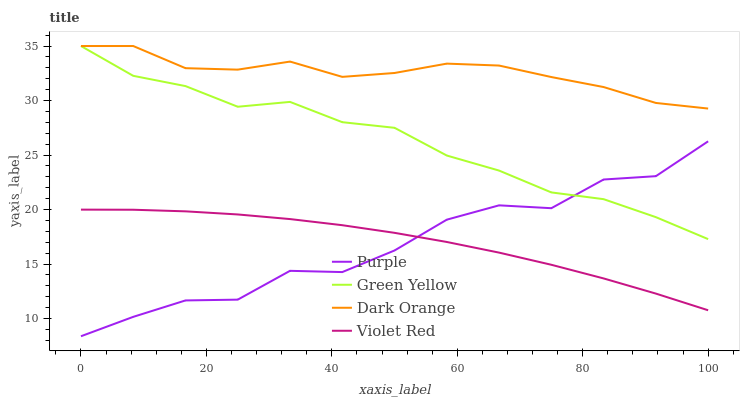Does Purple have the minimum area under the curve?
Answer yes or no. Yes. Does Dark Orange have the maximum area under the curve?
Answer yes or no. Yes. Does Violet Red have the minimum area under the curve?
Answer yes or no. No. Does Violet Red have the maximum area under the curve?
Answer yes or no. No. Is Violet Red the smoothest?
Answer yes or no. Yes. Is Purple the roughest?
Answer yes or no. Yes. Is Dark Orange the smoothest?
Answer yes or no. No. Is Dark Orange the roughest?
Answer yes or no. No. Does Purple have the lowest value?
Answer yes or no. Yes. Does Violet Red have the lowest value?
Answer yes or no. No. Does Green Yellow have the highest value?
Answer yes or no. Yes. Does Violet Red have the highest value?
Answer yes or no. No. Is Violet Red less than Green Yellow?
Answer yes or no. Yes. Is Green Yellow greater than Violet Red?
Answer yes or no. Yes. Does Purple intersect Violet Red?
Answer yes or no. Yes. Is Purple less than Violet Red?
Answer yes or no. No. Is Purple greater than Violet Red?
Answer yes or no. No. Does Violet Red intersect Green Yellow?
Answer yes or no. No. 